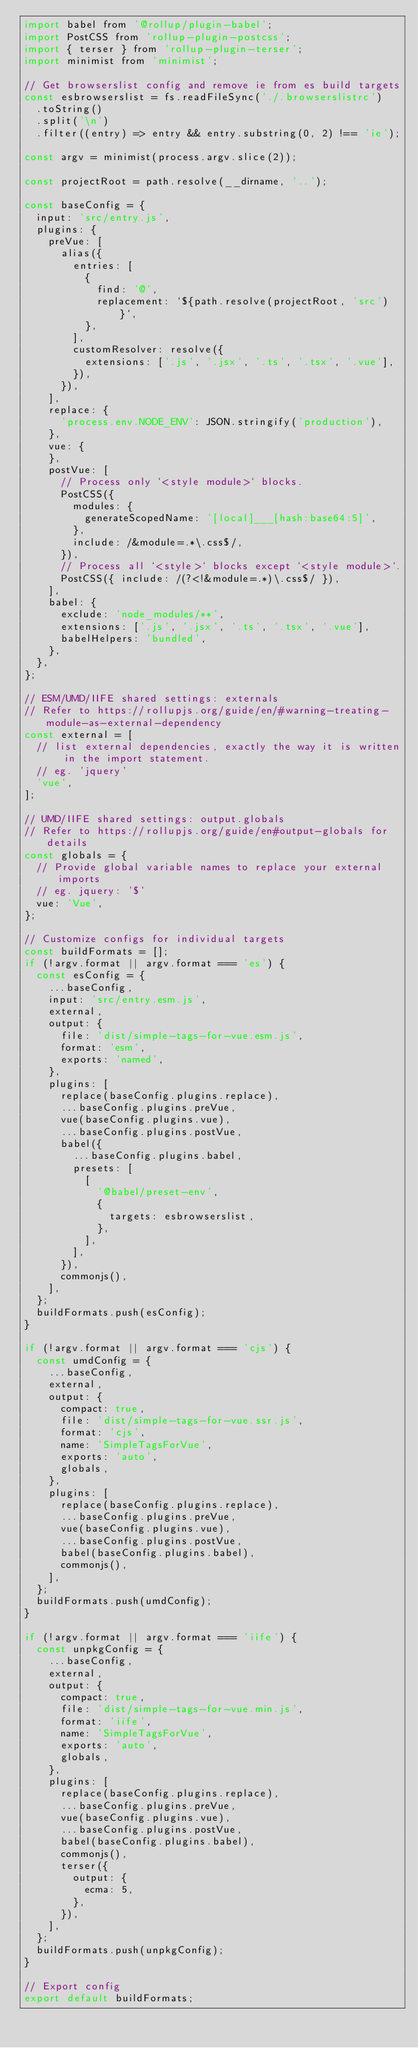<code> <loc_0><loc_0><loc_500><loc_500><_JavaScript_>import babel from '@rollup/plugin-babel';
import PostCSS from 'rollup-plugin-postcss';
import { terser } from 'rollup-plugin-terser';
import minimist from 'minimist';

// Get browserslist config and remove ie from es build targets
const esbrowserslist = fs.readFileSync('./.browserslistrc')
  .toString()
  .split('\n')
  .filter((entry) => entry && entry.substring(0, 2) !== 'ie');

const argv = minimist(process.argv.slice(2));

const projectRoot = path.resolve(__dirname, '..');

const baseConfig = {
  input: 'src/entry.js',
  plugins: {
    preVue: [
      alias({
        entries: [
          {
            find: '@',
            replacement: `${path.resolve(projectRoot, 'src')}`,
          },
        ],
        customResolver: resolve({
          extensions: ['.js', '.jsx', '.ts', '.tsx', '.vue'],
        }),
      }),
    ],
    replace: {
      'process.env.NODE_ENV': JSON.stringify('production'),
    },
    vue: {
    },
    postVue: [
      // Process only `<style module>` blocks.
      PostCSS({
        modules: {
          generateScopedName: '[local]___[hash:base64:5]',
        },
        include: /&module=.*\.css$/,
      }),
      // Process all `<style>` blocks except `<style module>`.
      PostCSS({ include: /(?<!&module=.*)\.css$/ }),
    ],
    babel: {
      exclude: 'node_modules/**',
      extensions: ['.js', '.jsx', '.ts', '.tsx', '.vue'],
      babelHelpers: 'bundled',
    },
  },
};

// ESM/UMD/IIFE shared settings: externals
// Refer to https://rollupjs.org/guide/en/#warning-treating-module-as-external-dependency
const external = [
  // list external dependencies, exactly the way it is written in the import statement.
  // eg. 'jquery'
  'vue',
];

// UMD/IIFE shared settings: output.globals
// Refer to https://rollupjs.org/guide/en#output-globals for details
const globals = {
  // Provide global variable names to replace your external imports
  // eg. jquery: '$'
  vue: 'Vue',
};

// Customize configs for individual targets
const buildFormats = [];
if (!argv.format || argv.format === 'es') {
  const esConfig = {
    ...baseConfig,
    input: 'src/entry.esm.js',
    external,
    output: {
      file: 'dist/simple-tags-for-vue.esm.js',
      format: 'esm',
      exports: 'named',
    },
    plugins: [
      replace(baseConfig.plugins.replace),
      ...baseConfig.plugins.preVue,
      vue(baseConfig.plugins.vue),
      ...baseConfig.plugins.postVue,
      babel({
        ...baseConfig.plugins.babel,
        presets: [
          [
            '@babel/preset-env',
            {
              targets: esbrowserslist,
            },
          ],
        ],
      }),
      commonjs(),
    ],
  };
  buildFormats.push(esConfig);
}

if (!argv.format || argv.format === 'cjs') {
  const umdConfig = {
    ...baseConfig,
    external,
    output: {
      compact: true,
      file: 'dist/simple-tags-for-vue.ssr.js',
      format: 'cjs',
      name: 'SimpleTagsForVue',
      exports: 'auto',
      globals,
    },
    plugins: [
      replace(baseConfig.plugins.replace),
      ...baseConfig.plugins.preVue,
      vue(baseConfig.plugins.vue),
      ...baseConfig.plugins.postVue,
      babel(baseConfig.plugins.babel),
      commonjs(),
    ],
  };
  buildFormats.push(umdConfig);
}

if (!argv.format || argv.format === 'iife') {
  const unpkgConfig = {
    ...baseConfig,
    external,
    output: {
      compact: true,
      file: 'dist/simple-tags-for-vue.min.js',
      format: 'iife',
      name: 'SimpleTagsForVue',
      exports: 'auto',
      globals,
    },
    plugins: [
      replace(baseConfig.plugins.replace),
      ...baseConfig.plugins.preVue,
      vue(baseConfig.plugins.vue),
      ...baseConfig.plugins.postVue,
      babel(baseConfig.plugins.babel),
      commonjs(),
      terser({
        output: {
          ecma: 5,
        },
      }),
    ],
  };
  buildFormats.push(unpkgConfig);
}

// Export config
export default buildFormats;
</code> 